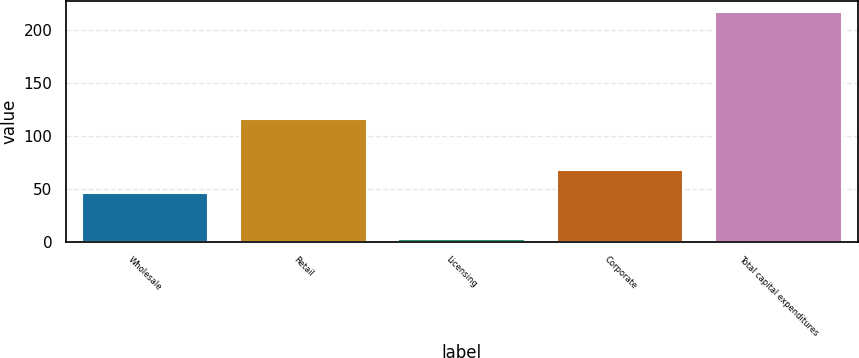<chart> <loc_0><loc_0><loc_500><loc_500><bar_chart><fcel>Wholesale<fcel>Retail<fcel>Licensing<fcel>Corporate<fcel>Total capital expenditures<nl><fcel>46<fcel>116.1<fcel>2.4<fcel>67.47<fcel>217.1<nl></chart> 